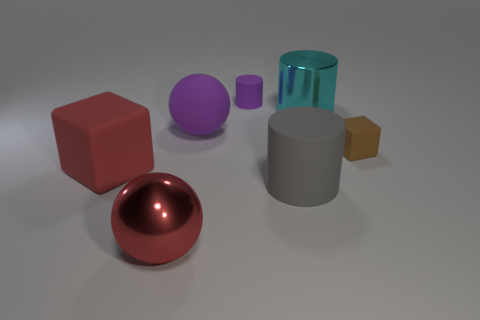Add 1 purple matte cylinders. How many objects exist? 8 Subtract all balls. How many objects are left? 5 Subtract 0 cyan balls. How many objects are left? 7 Subtract all big blue cubes. Subtract all cyan objects. How many objects are left? 6 Add 5 big rubber balls. How many big rubber balls are left? 6 Add 4 large red objects. How many large red objects exist? 6 